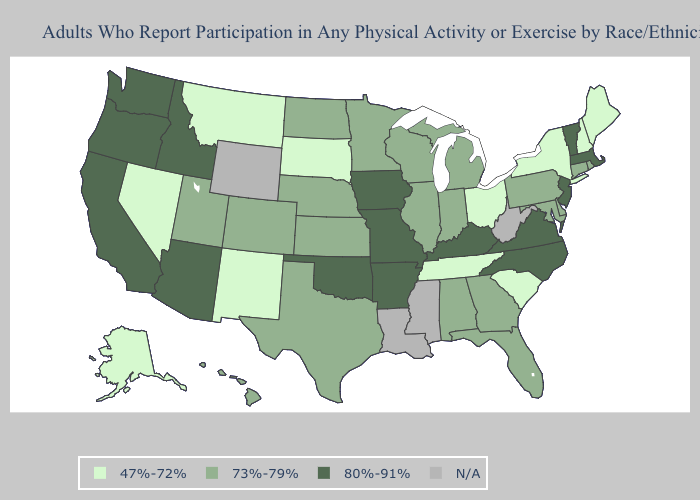What is the value of Michigan?
Give a very brief answer. 73%-79%. Does Connecticut have the lowest value in the Northeast?
Quick response, please. No. What is the lowest value in states that border Connecticut?
Write a very short answer. 47%-72%. What is the highest value in the South ?
Concise answer only. 80%-91%. Which states hav the highest value in the West?
Short answer required. Arizona, California, Idaho, Oregon, Washington. Name the states that have a value in the range 80%-91%?
Keep it brief. Arizona, Arkansas, California, Idaho, Iowa, Kentucky, Massachusetts, Missouri, New Jersey, North Carolina, Oklahoma, Oregon, Vermont, Virginia, Washington. What is the highest value in the USA?
Short answer required. 80%-91%. Does Idaho have the highest value in the West?
Give a very brief answer. Yes. Name the states that have a value in the range 80%-91%?
Write a very short answer. Arizona, Arkansas, California, Idaho, Iowa, Kentucky, Massachusetts, Missouri, New Jersey, North Carolina, Oklahoma, Oregon, Vermont, Virginia, Washington. Does South Dakota have the lowest value in the MidWest?
Quick response, please. Yes. Name the states that have a value in the range 73%-79%?
Quick response, please. Alabama, Colorado, Connecticut, Delaware, Florida, Georgia, Hawaii, Illinois, Indiana, Kansas, Maryland, Michigan, Minnesota, Nebraska, North Dakota, Pennsylvania, Rhode Island, Texas, Utah, Wisconsin. Name the states that have a value in the range 80%-91%?
Keep it brief. Arizona, Arkansas, California, Idaho, Iowa, Kentucky, Massachusetts, Missouri, New Jersey, North Carolina, Oklahoma, Oregon, Vermont, Virginia, Washington. Which states have the lowest value in the USA?
Write a very short answer. Alaska, Maine, Montana, Nevada, New Hampshire, New Mexico, New York, Ohio, South Carolina, South Dakota, Tennessee. Name the states that have a value in the range 73%-79%?
Quick response, please. Alabama, Colorado, Connecticut, Delaware, Florida, Georgia, Hawaii, Illinois, Indiana, Kansas, Maryland, Michigan, Minnesota, Nebraska, North Dakota, Pennsylvania, Rhode Island, Texas, Utah, Wisconsin. 